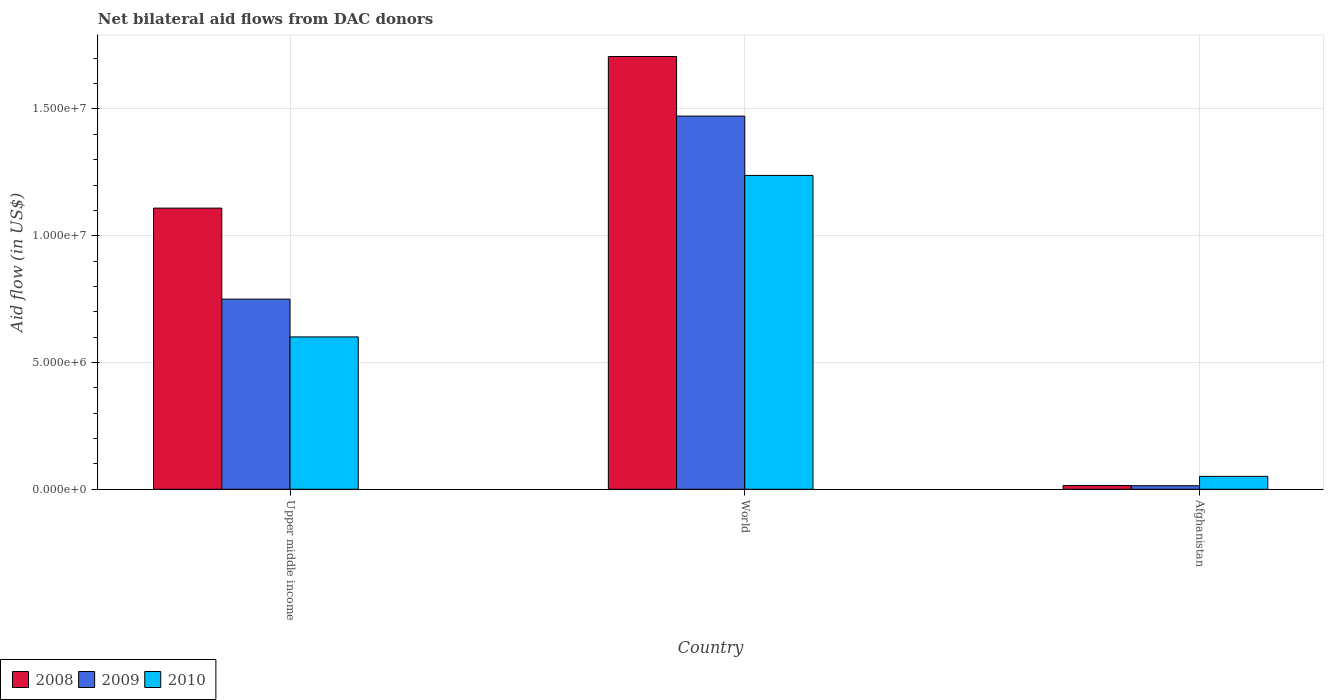Are the number of bars per tick equal to the number of legend labels?
Provide a succinct answer. Yes. Are the number of bars on each tick of the X-axis equal?
Your answer should be very brief. Yes. What is the label of the 1st group of bars from the left?
Provide a short and direct response. Upper middle income. In how many cases, is the number of bars for a given country not equal to the number of legend labels?
Offer a terse response. 0. What is the net bilateral aid flow in 2010 in Upper middle income?
Your response must be concise. 6.01e+06. Across all countries, what is the maximum net bilateral aid flow in 2010?
Your response must be concise. 1.24e+07. Across all countries, what is the minimum net bilateral aid flow in 2009?
Your answer should be very brief. 1.40e+05. In which country was the net bilateral aid flow in 2009 minimum?
Give a very brief answer. Afghanistan. What is the total net bilateral aid flow in 2010 in the graph?
Ensure brevity in your answer.  1.89e+07. What is the difference between the net bilateral aid flow in 2008 in Upper middle income and that in World?
Ensure brevity in your answer.  -5.98e+06. What is the difference between the net bilateral aid flow in 2008 in Upper middle income and the net bilateral aid flow in 2009 in World?
Give a very brief answer. -3.63e+06. What is the average net bilateral aid flow in 2008 per country?
Your answer should be compact. 9.44e+06. What is the difference between the net bilateral aid flow of/in 2009 and net bilateral aid flow of/in 2010 in Upper middle income?
Your response must be concise. 1.49e+06. What is the ratio of the net bilateral aid flow in 2008 in Afghanistan to that in World?
Your answer should be very brief. 0.01. Is the difference between the net bilateral aid flow in 2009 in Upper middle income and World greater than the difference between the net bilateral aid flow in 2010 in Upper middle income and World?
Keep it short and to the point. No. What is the difference between the highest and the second highest net bilateral aid flow in 2009?
Offer a very short reply. 1.46e+07. What is the difference between the highest and the lowest net bilateral aid flow in 2010?
Your response must be concise. 1.19e+07. Is the sum of the net bilateral aid flow in 2010 in Afghanistan and Upper middle income greater than the maximum net bilateral aid flow in 2008 across all countries?
Give a very brief answer. No. What does the 2nd bar from the left in Afghanistan represents?
Your answer should be compact. 2009. What does the 1st bar from the right in Afghanistan represents?
Your answer should be compact. 2010. Is it the case that in every country, the sum of the net bilateral aid flow in 2008 and net bilateral aid flow in 2010 is greater than the net bilateral aid flow in 2009?
Give a very brief answer. Yes. How many bars are there?
Offer a terse response. 9. Are all the bars in the graph horizontal?
Give a very brief answer. No. Are the values on the major ticks of Y-axis written in scientific E-notation?
Your answer should be very brief. Yes. Does the graph contain any zero values?
Your answer should be very brief. No. How many legend labels are there?
Provide a short and direct response. 3. What is the title of the graph?
Your answer should be very brief. Net bilateral aid flows from DAC donors. What is the label or title of the Y-axis?
Ensure brevity in your answer.  Aid flow (in US$). What is the Aid flow (in US$) of 2008 in Upper middle income?
Offer a terse response. 1.11e+07. What is the Aid flow (in US$) of 2009 in Upper middle income?
Your answer should be very brief. 7.50e+06. What is the Aid flow (in US$) of 2010 in Upper middle income?
Your response must be concise. 6.01e+06. What is the Aid flow (in US$) in 2008 in World?
Your answer should be compact. 1.71e+07. What is the Aid flow (in US$) in 2009 in World?
Provide a short and direct response. 1.47e+07. What is the Aid flow (in US$) of 2010 in World?
Provide a short and direct response. 1.24e+07. What is the Aid flow (in US$) of 2008 in Afghanistan?
Ensure brevity in your answer.  1.50e+05. What is the Aid flow (in US$) of 2009 in Afghanistan?
Provide a short and direct response. 1.40e+05. What is the Aid flow (in US$) in 2010 in Afghanistan?
Provide a short and direct response. 5.10e+05. Across all countries, what is the maximum Aid flow (in US$) in 2008?
Offer a very short reply. 1.71e+07. Across all countries, what is the maximum Aid flow (in US$) of 2009?
Provide a succinct answer. 1.47e+07. Across all countries, what is the maximum Aid flow (in US$) in 2010?
Your answer should be very brief. 1.24e+07. Across all countries, what is the minimum Aid flow (in US$) of 2009?
Your answer should be compact. 1.40e+05. Across all countries, what is the minimum Aid flow (in US$) in 2010?
Your answer should be compact. 5.10e+05. What is the total Aid flow (in US$) of 2008 in the graph?
Keep it short and to the point. 2.83e+07. What is the total Aid flow (in US$) in 2009 in the graph?
Provide a succinct answer. 2.24e+07. What is the total Aid flow (in US$) in 2010 in the graph?
Offer a very short reply. 1.89e+07. What is the difference between the Aid flow (in US$) of 2008 in Upper middle income and that in World?
Keep it short and to the point. -5.98e+06. What is the difference between the Aid flow (in US$) in 2009 in Upper middle income and that in World?
Your answer should be very brief. -7.22e+06. What is the difference between the Aid flow (in US$) of 2010 in Upper middle income and that in World?
Offer a very short reply. -6.37e+06. What is the difference between the Aid flow (in US$) of 2008 in Upper middle income and that in Afghanistan?
Offer a very short reply. 1.09e+07. What is the difference between the Aid flow (in US$) of 2009 in Upper middle income and that in Afghanistan?
Provide a short and direct response. 7.36e+06. What is the difference between the Aid flow (in US$) in 2010 in Upper middle income and that in Afghanistan?
Provide a succinct answer. 5.50e+06. What is the difference between the Aid flow (in US$) of 2008 in World and that in Afghanistan?
Keep it short and to the point. 1.69e+07. What is the difference between the Aid flow (in US$) of 2009 in World and that in Afghanistan?
Provide a short and direct response. 1.46e+07. What is the difference between the Aid flow (in US$) of 2010 in World and that in Afghanistan?
Give a very brief answer. 1.19e+07. What is the difference between the Aid flow (in US$) of 2008 in Upper middle income and the Aid flow (in US$) of 2009 in World?
Your answer should be very brief. -3.63e+06. What is the difference between the Aid flow (in US$) of 2008 in Upper middle income and the Aid flow (in US$) of 2010 in World?
Ensure brevity in your answer.  -1.29e+06. What is the difference between the Aid flow (in US$) in 2009 in Upper middle income and the Aid flow (in US$) in 2010 in World?
Keep it short and to the point. -4.88e+06. What is the difference between the Aid flow (in US$) of 2008 in Upper middle income and the Aid flow (in US$) of 2009 in Afghanistan?
Keep it short and to the point. 1.10e+07. What is the difference between the Aid flow (in US$) of 2008 in Upper middle income and the Aid flow (in US$) of 2010 in Afghanistan?
Your response must be concise. 1.06e+07. What is the difference between the Aid flow (in US$) in 2009 in Upper middle income and the Aid flow (in US$) in 2010 in Afghanistan?
Offer a terse response. 6.99e+06. What is the difference between the Aid flow (in US$) of 2008 in World and the Aid flow (in US$) of 2009 in Afghanistan?
Make the answer very short. 1.69e+07. What is the difference between the Aid flow (in US$) of 2008 in World and the Aid flow (in US$) of 2010 in Afghanistan?
Provide a short and direct response. 1.66e+07. What is the difference between the Aid flow (in US$) of 2009 in World and the Aid flow (in US$) of 2010 in Afghanistan?
Your answer should be compact. 1.42e+07. What is the average Aid flow (in US$) of 2008 per country?
Keep it short and to the point. 9.44e+06. What is the average Aid flow (in US$) in 2009 per country?
Give a very brief answer. 7.45e+06. What is the average Aid flow (in US$) of 2010 per country?
Make the answer very short. 6.30e+06. What is the difference between the Aid flow (in US$) in 2008 and Aid flow (in US$) in 2009 in Upper middle income?
Your answer should be very brief. 3.59e+06. What is the difference between the Aid flow (in US$) in 2008 and Aid flow (in US$) in 2010 in Upper middle income?
Your answer should be very brief. 5.08e+06. What is the difference between the Aid flow (in US$) of 2009 and Aid flow (in US$) of 2010 in Upper middle income?
Keep it short and to the point. 1.49e+06. What is the difference between the Aid flow (in US$) in 2008 and Aid flow (in US$) in 2009 in World?
Keep it short and to the point. 2.35e+06. What is the difference between the Aid flow (in US$) of 2008 and Aid flow (in US$) of 2010 in World?
Provide a succinct answer. 4.69e+06. What is the difference between the Aid flow (in US$) in 2009 and Aid flow (in US$) in 2010 in World?
Provide a succinct answer. 2.34e+06. What is the difference between the Aid flow (in US$) in 2008 and Aid flow (in US$) in 2010 in Afghanistan?
Your answer should be compact. -3.60e+05. What is the difference between the Aid flow (in US$) of 2009 and Aid flow (in US$) of 2010 in Afghanistan?
Your answer should be compact. -3.70e+05. What is the ratio of the Aid flow (in US$) of 2008 in Upper middle income to that in World?
Offer a very short reply. 0.65. What is the ratio of the Aid flow (in US$) of 2009 in Upper middle income to that in World?
Your answer should be very brief. 0.51. What is the ratio of the Aid flow (in US$) in 2010 in Upper middle income to that in World?
Offer a terse response. 0.49. What is the ratio of the Aid flow (in US$) in 2008 in Upper middle income to that in Afghanistan?
Provide a succinct answer. 73.93. What is the ratio of the Aid flow (in US$) of 2009 in Upper middle income to that in Afghanistan?
Your response must be concise. 53.57. What is the ratio of the Aid flow (in US$) of 2010 in Upper middle income to that in Afghanistan?
Keep it short and to the point. 11.78. What is the ratio of the Aid flow (in US$) in 2008 in World to that in Afghanistan?
Offer a very short reply. 113.8. What is the ratio of the Aid flow (in US$) in 2009 in World to that in Afghanistan?
Provide a succinct answer. 105.14. What is the ratio of the Aid flow (in US$) of 2010 in World to that in Afghanistan?
Your response must be concise. 24.27. What is the difference between the highest and the second highest Aid flow (in US$) of 2008?
Give a very brief answer. 5.98e+06. What is the difference between the highest and the second highest Aid flow (in US$) in 2009?
Make the answer very short. 7.22e+06. What is the difference between the highest and the second highest Aid flow (in US$) in 2010?
Offer a very short reply. 6.37e+06. What is the difference between the highest and the lowest Aid flow (in US$) in 2008?
Give a very brief answer. 1.69e+07. What is the difference between the highest and the lowest Aid flow (in US$) in 2009?
Keep it short and to the point. 1.46e+07. What is the difference between the highest and the lowest Aid flow (in US$) of 2010?
Keep it short and to the point. 1.19e+07. 